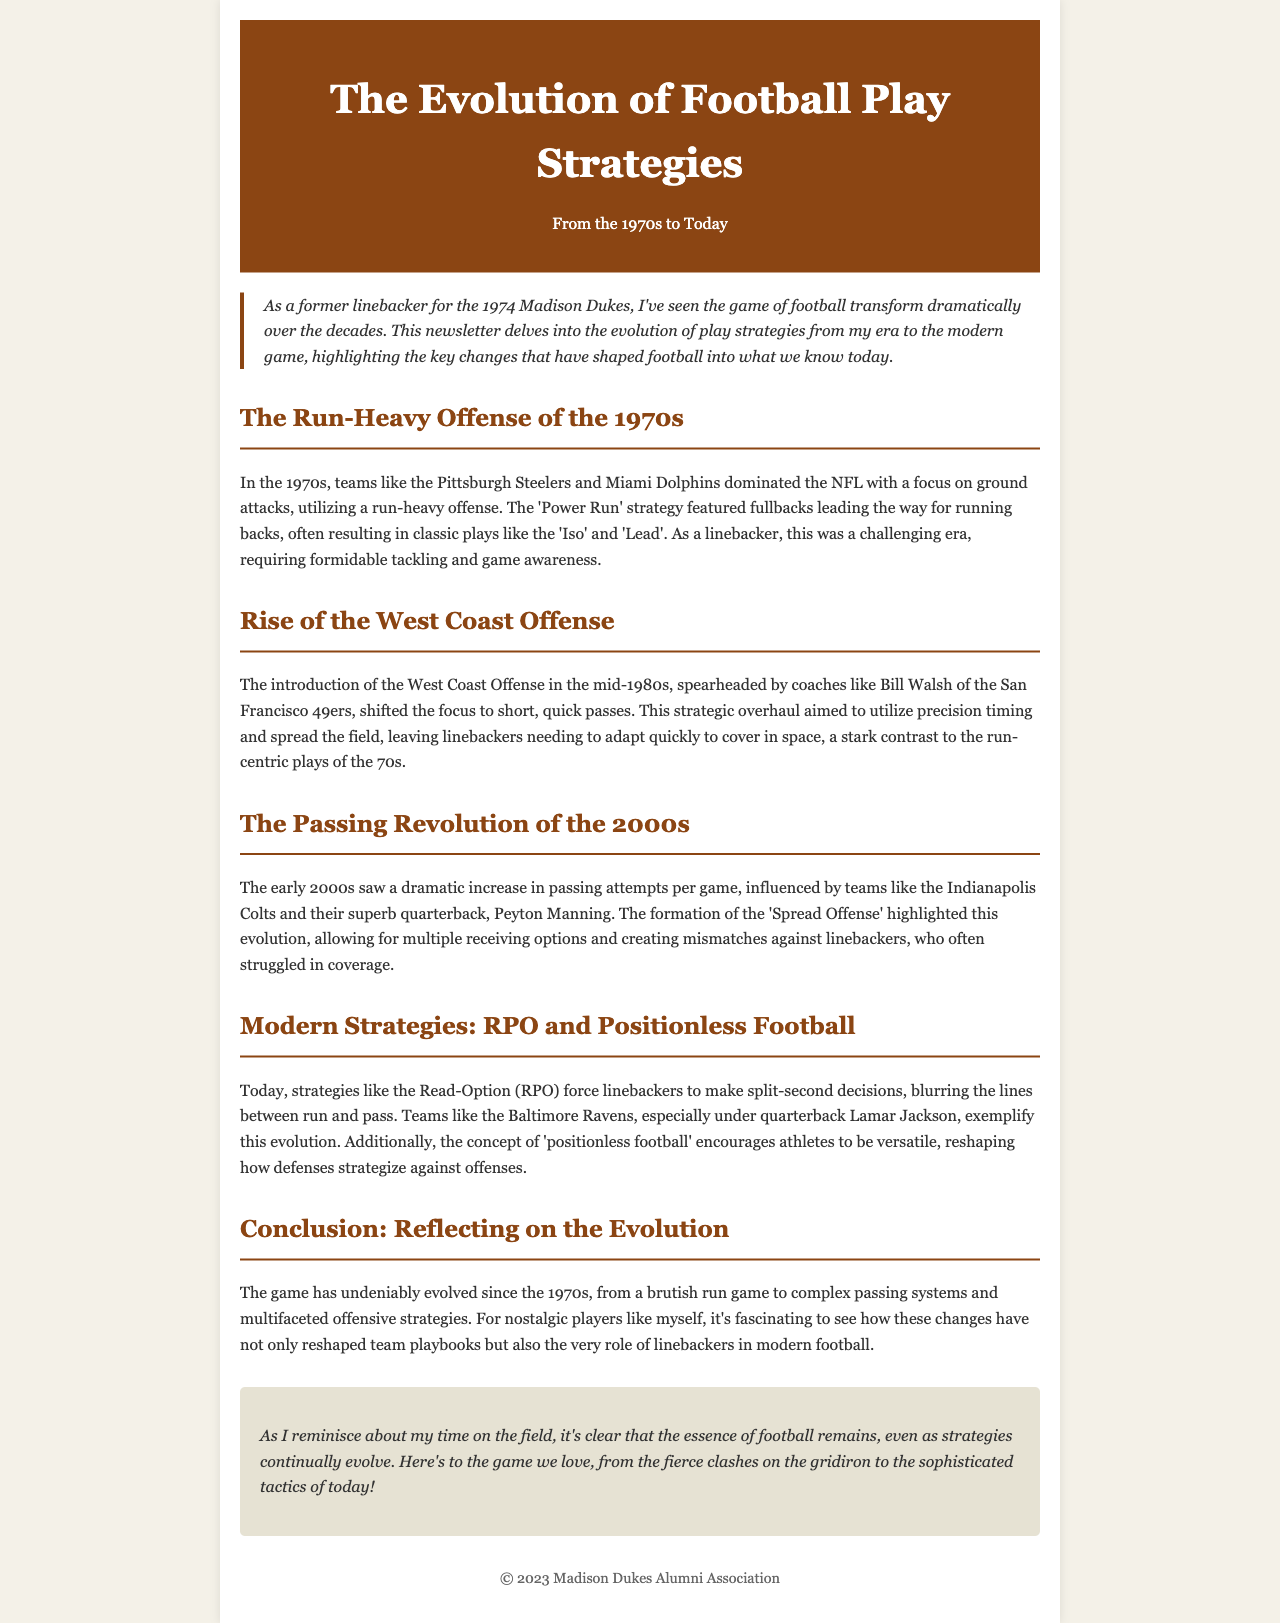What was the dominant offense style in the 1970s? The document states that teams in the 1970s focused on a run-heavy offense, emphasizing ground attacks.
Answer: run-heavy offense Who introduced the West Coast Offense? The document mentions that the West Coast Offense was introduced by coaches like Bill Walsh.
Answer: Bill Walsh What significant change occurred in the 2000s regarding passing? According to the document, the early 2000s saw a dramatic increase in passing attempts per game.
Answer: increase in passing attempts What is the modern strategy that forces linebackers to make quick decisions? The document describes the Read-Option (RPO) as forcing linebackers to make split-second decisions.
Answer: Read-Option (RPO) What concept encourages versatility in modern football players? The document states that the concept of 'positionless football' encourages athletes to be versatile.
Answer: positionless football In which era did the 'Spread Offense' become prominent? The document explains that the 'Spread Offense' highlighted the evolution in the early 2000s.
Answer: early 2000s Which NFL team is associated with Lamar Jackson? The document notes that the Baltimore Ravens exemplify modern football evolution under quarterback Lamar Jackson.
Answer: Baltimore Ravens How does the document describe the shift in play strategies from the 1970s? The document states that the game has evolved from a brutish run game to complex passing systems.
Answer: complex passing systems 